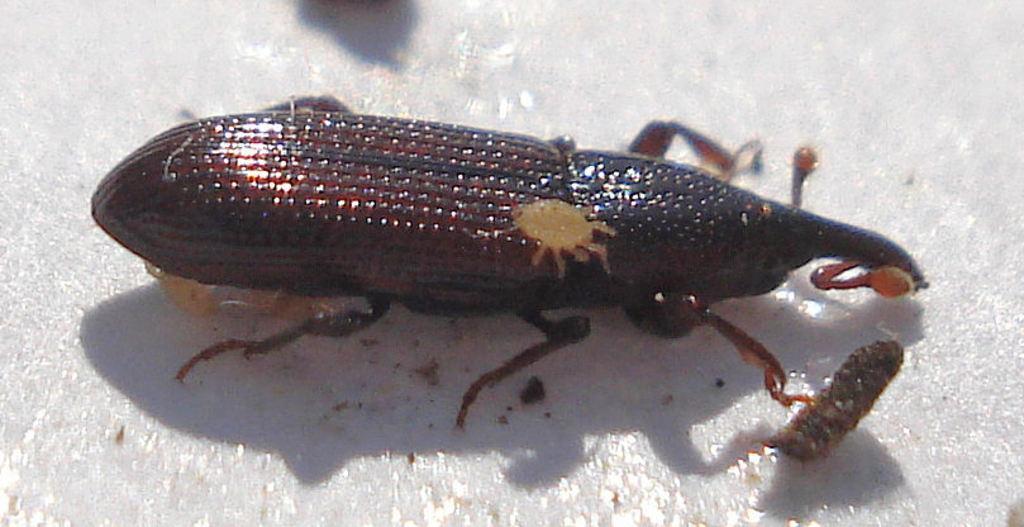Can you describe this image briefly? In this picture it looks like an insect on the ground. 